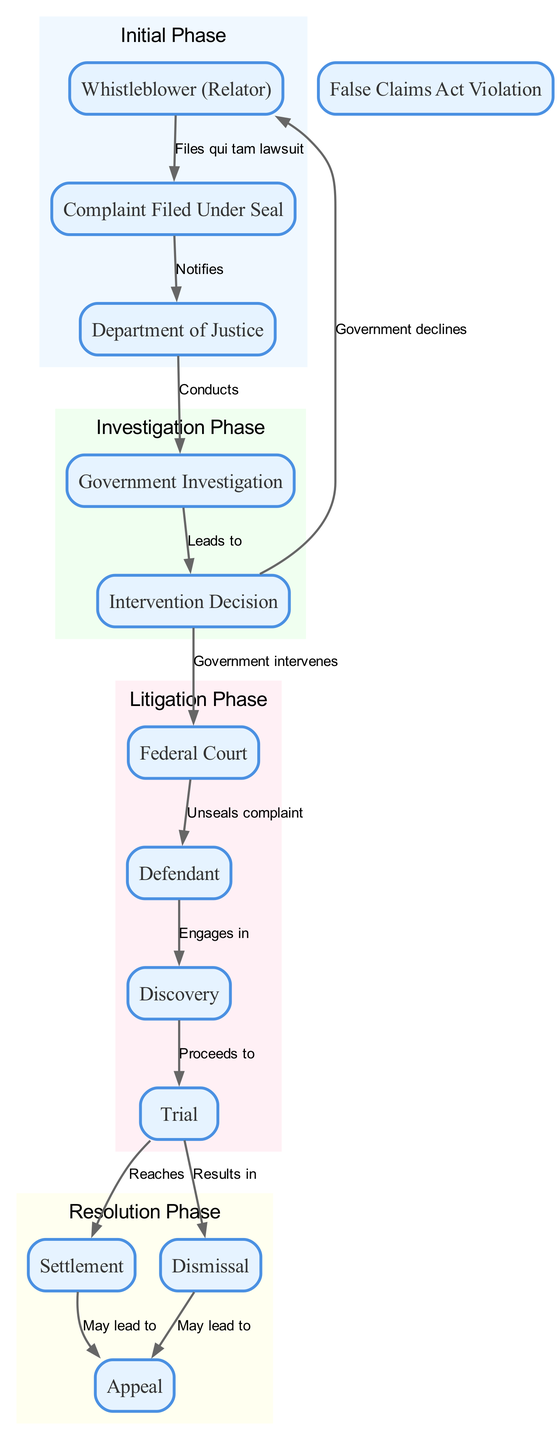What is the first step in the process flow? The first step is initiated by the Whistleblower (Relator), who files a qui tam lawsuit, leading to the Complaint Filed Under Seal.
Answer: Complaint Filed Under Seal How many nodes are in the diagram? Counting the unique elements listed under nodes, there are thirteen distinct elements in the diagram.
Answer: 13 What happens after the Complaint is Filed Under Seal? After the Complaint is Filed Under Seal, it Notifies the Department of Justice according to the flow of the diagram.
Answer: Notifies What leads to the Government Investigation? The Government Investigation is conducted as a result of the Department of Justice receiving notification of the Complaint Filed Under Seal.
Answer: Conducts What are the possible outcomes after the Intervention Decision? After the Intervention Decision, the possible outcomes are either the Government intervenes leading to proceedings in Federal Court or the Government declines which circles back to the Whistleblower (Relator).
Answer: Government intervenes, Government declines Which node follows the Trial node? The Trial node can proceed to either a Settlement or a Dismissal depending on the case outcome, from which both can lead to the Appeal node.
Answer: Settlement, Dismissal What initiates the Discovery phase? The Discovery phase is initiated when the Defendant engages in the process after the complaint is unsealed by the Federal Court.
Answer: Engages in What nodes are grouped under the Resolution Phase? The nodes grouped under the Resolution Phase include Settlement, Dismissal, and Appeal, indicating the resolution options after litigation.
Answer: Settlement, Dismissal, Appeal What can result from a Settlement? A Settlement may lead to an Appeal, indicating that disputes can continue even after a settlement is reached.
Answer: May lead to 